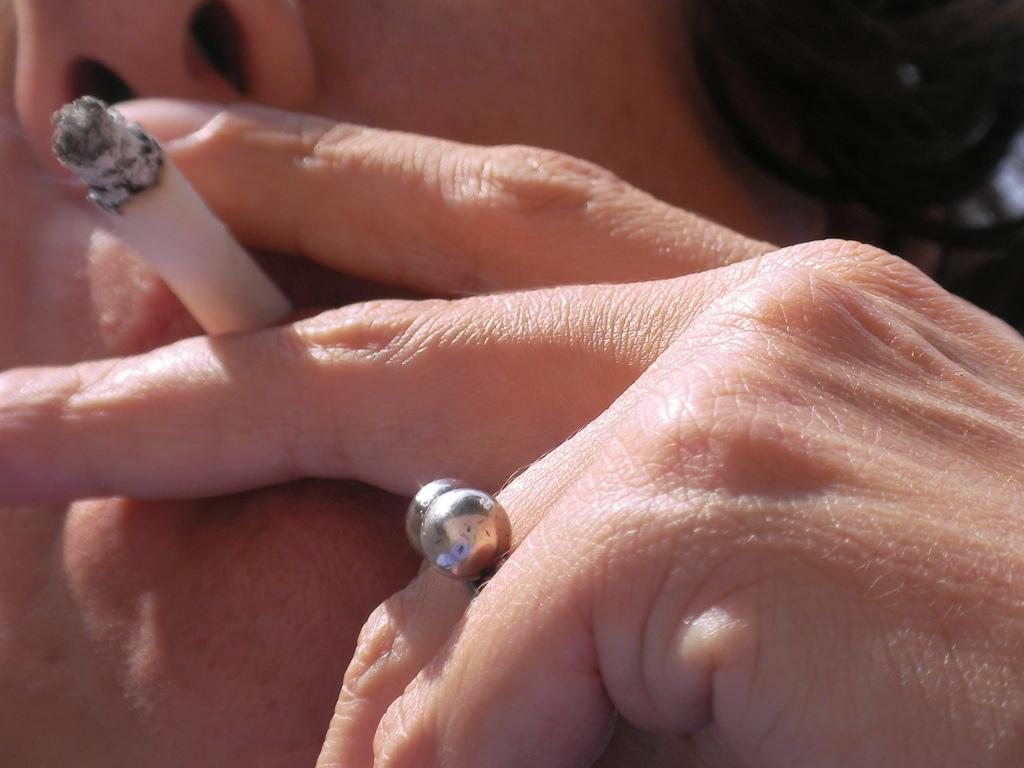Who or what is the main subject in the image? There is a person in the image. What is the person holding in the image? The person is holding a cigarette with his fingers. Are there any accessories visible on the person in the image? Yes, the person is wearing a ring on his finger. Can you see a frog hopping in the image? No, there is no frog present in the image. What type of wax is being used by the person in the image? There is no wax visible or mentioned in the image. 